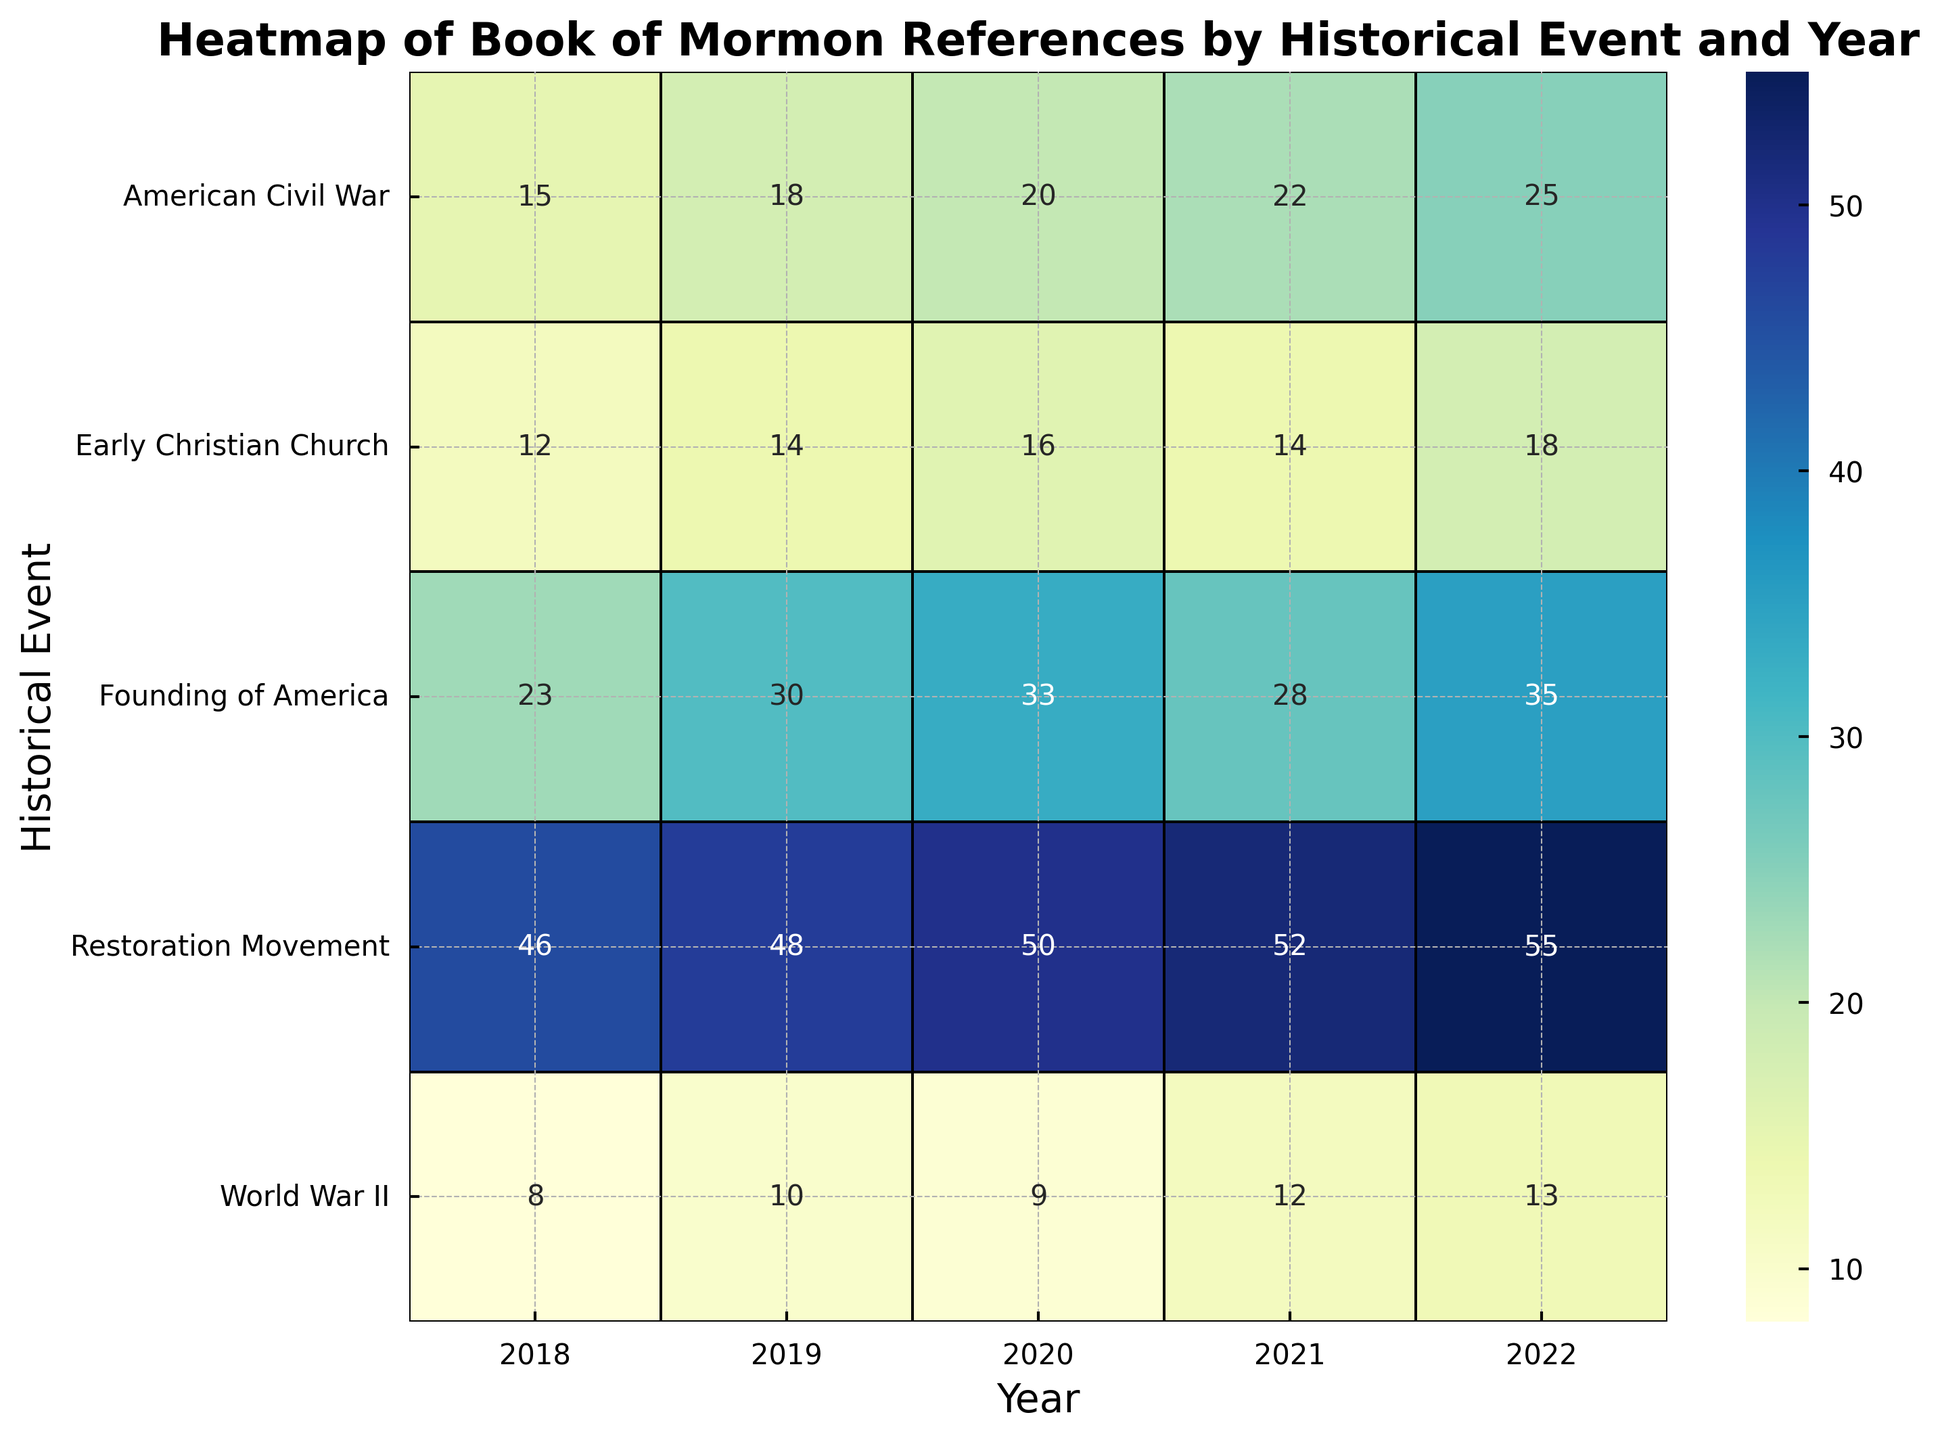What's the historical event with the most Book of Mormon references in 2019? Look at the column for the year 2019 and compare the numbers for each historical event. The Restoration Movement has the highest value of 48.
Answer: The Restoration Movement Which year had the fewest references for the American Civil War? Examine the values for the American Civil War across all years. The fewest references, 15, are in 2018.
Answer: 2018 By how many references did the Founding of America discussion increase from 2021 to 2022? Find the references for the Founding of America in 2021 and 2022 (28 and 35 respectively) and subtract the former from the latter. 35 - 28 = 7.
Answer: 7 What's the average number of references for World War II across all years? Sum the references for World War II for each year (8 + 10 + 9 + 12 + 13 = 52) and divide by the number of years (5). 52 / 5 = 10.4
Answer: 10.4 Which event had the largest increase in references from 2018 to 2022? Calculate the change in references from 2018 to 2022 for each event: Founding of America (35-23), American Civil War (25-15), Early Christian Church (18-12), World War II (13-8), Restoration Movement (55-46). The Restoration Movement saw the largest increase of 9.
Answer: Restoration Movement In which year was the discussion on Early Christian Church the highest? Compare the numbers for the Early Christian Church across all years and find the highest (2022 with 18 references).
Answer: 2022 How did the number of references for the Restoration Movement change from 2018 to 2019? Compare the values for the Restoration Movement in 2018 (46) and 2019 (48). It increased by 48 - 46 = 2.
Answer: Increased by 2 Was the discussion on World War II ever higher than the discussion on Early Christian Church? Compare the values for World War II and Early Christian Church for each year. The Early Christian Church always has higher references than World War II in each year.
Answer: No By how many references did the discussions on the American Civil War increase from 2019 to 2021? Check the values for the American Civil War in 2019 (18) and 2021 (22) and find the difference, 22 - 18 = 4.
Answer: 4 Which year had the highest total number of references for all events combined? Sum the references across all events for each year:
2018: 23 + 15 + 12 + 8 + 46 = 104,
2019: 30 + 18 + 14 + 10 + 48 = 120,
2020: 33 + 20 + 16 + 9 + 50 = 128,
2021: 28 + 22 + 14 + 12 + 52 = 128,
2022: 35 + 25 + 18 + 13 + 55 = 146.
Thus, 2022 had the highest total with 146 references.
Answer: 2022 